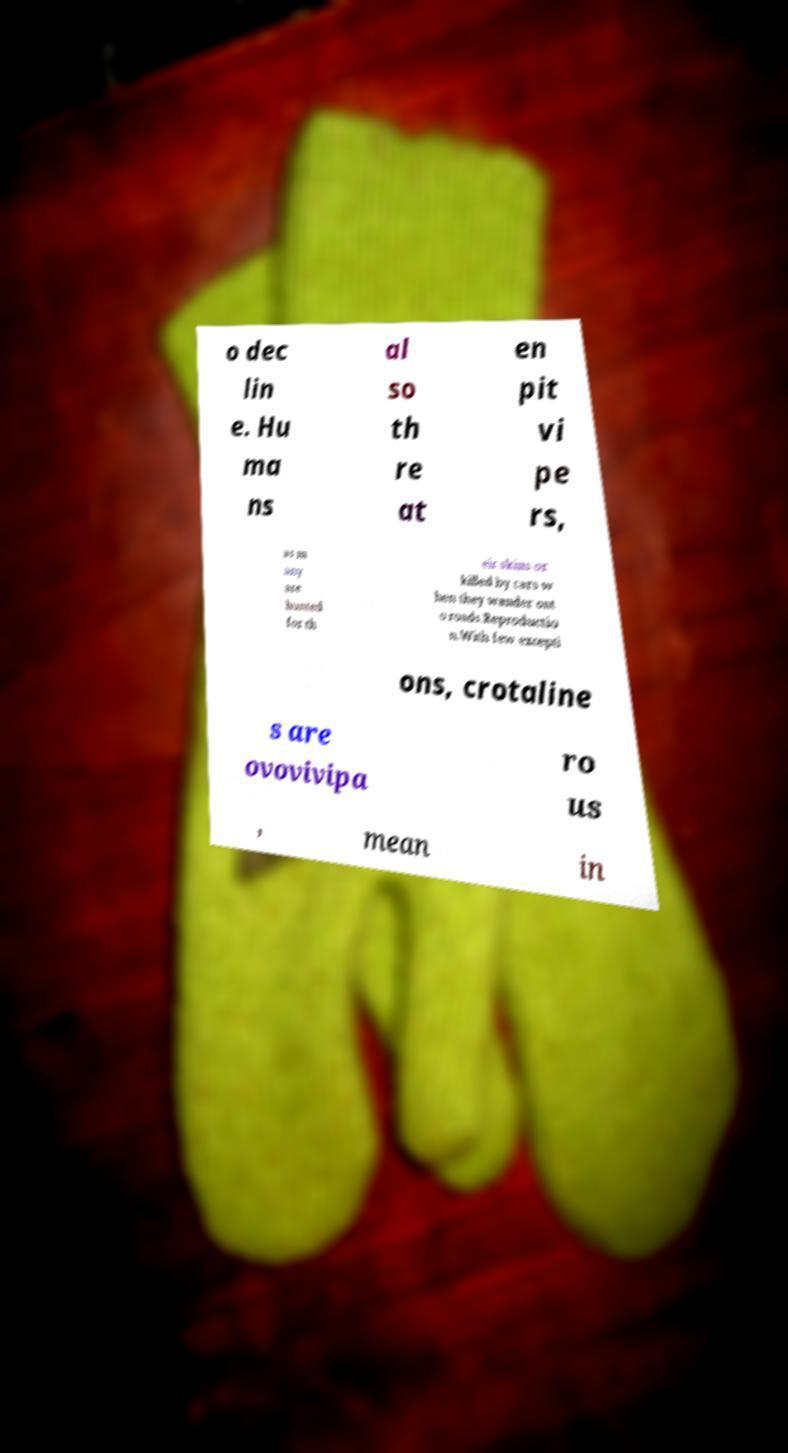What messages or text are displayed in this image? I need them in a readable, typed format. o dec lin e. Hu ma ns al so th re at en pit vi pe rs, as m any are hunted for th eir skins or killed by cars w hen they wander ont o roads.Reproductio n.With few excepti ons, crotaline s are ovovivipa ro us , mean in 